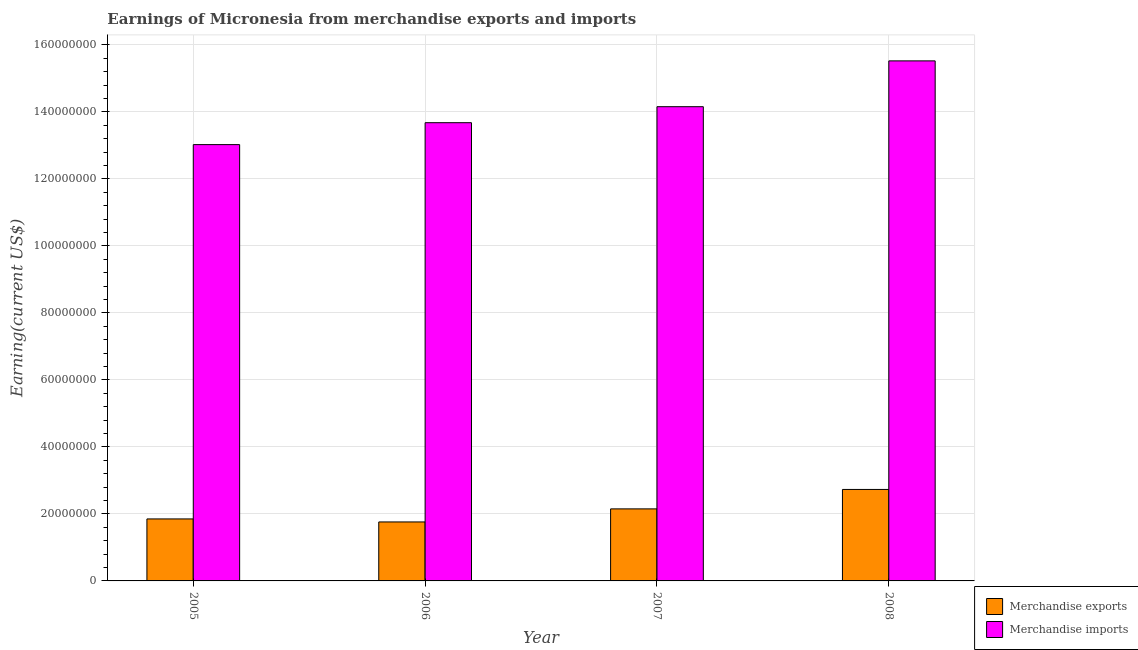How many different coloured bars are there?
Keep it short and to the point. 2. How many groups of bars are there?
Your answer should be very brief. 4. How many bars are there on the 1st tick from the left?
Your answer should be very brief. 2. In how many cases, is the number of bars for a given year not equal to the number of legend labels?
Offer a very short reply. 0. What is the earnings from merchandise imports in 2008?
Make the answer very short. 1.55e+08. Across all years, what is the maximum earnings from merchandise imports?
Your answer should be compact. 1.55e+08. Across all years, what is the minimum earnings from merchandise imports?
Ensure brevity in your answer.  1.30e+08. In which year was the earnings from merchandise exports maximum?
Make the answer very short. 2008. In which year was the earnings from merchandise exports minimum?
Offer a very short reply. 2006. What is the total earnings from merchandise imports in the graph?
Give a very brief answer. 5.64e+08. What is the difference between the earnings from merchandise imports in 2005 and that in 2008?
Offer a terse response. -2.50e+07. What is the difference between the earnings from merchandise exports in 2006 and the earnings from merchandise imports in 2007?
Provide a succinct answer. -3.90e+06. What is the average earnings from merchandise imports per year?
Offer a terse response. 1.41e+08. What is the ratio of the earnings from merchandise exports in 2005 to that in 2007?
Your answer should be compact. 0.86. Is the earnings from merchandise exports in 2005 less than that in 2008?
Your answer should be very brief. Yes. What is the difference between the highest and the second highest earnings from merchandise exports?
Offer a terse response. 5.80e+06. What is the difference between the highest and the lowest earnings from merchandise exports?
Provide a succinct answer. 9.70e+06. In how many years, is the earnings from merchandise exports greater than the average earnings from merchandise exports taken over all years?
Give a very brief answer. 2. What does the 1st bar from the right in 2005 represents?
Ensure brevity in your answer.  Merchandise imports. How many bars are there?
Give a very brief answer. 8. Are all the bars in the graph horizontal?
Offer a very short reply. No. How many years are there in the graph?
Offer a very short reply. 4. Are the values on the major ticks of Y-axis written in scientific E-notation?
Ensure brevity in your answer.  No. Does the graph contain any zero values?
Make the answer very short. No. Does the graph contain grids?
Your answer should be very brief. Yes. How are the legend labels stacked?
Provide a short and direct response. Vertical. What is the title of the graph?
Offer a terse response. Earnings of Micronesia from merchandise exports and imports. What is the label or title of the Y-axis?
Offer a terse response. Earning(current US$). What is the Earning(current US$) of Merchandise exports in 2005?
Your answer should be very brief. 1.85e+07. What is the Earning(current US$) in Merchandise imports in 2005?
Your response must be concise. 1.30e+08. What is the Earning(current US$) in Merchandise exports in 2006?
Give a very brief answer. 1.76e+07. What is the Earning(current US$) in Merchandise imports in 2006?
Give a very brief answer. 1.37e+08. What is the Earning(current US$) in Merchandise exports in 2007?
Give a very brief answer. 2.15e+07. What is the Earning(current US$) in Merchandise imports in 2007?
Your answer should be very brief. 1.42e+08. What is the Earning(current US$) in Merchandise exports in 2008?
Make the answer very short. 2.73e+07. What is the Earning(current US$) of Merchandise imports in 2008?
Your answer should be compact. 1.55e+08. Across all years, what is the maximum Earning(current US$) of Merchandise exports?
Provide a short and direct response. 2.73e+07. Across all years, what is the maximum Earning(current US$) of Merchandise imports?
Your answer should be very brief. 1.55e+08. Across all years, what is the minimum Earning(current US$) in Merchandise exports?
Give a very brief answer. 1.76e+07. Across all years, what is the minimum Earning(current US$) of Merchandise imports?
Provide a succinct answer. 1.30e+08. What is the total Earning(current US$) in Merchandise exports in the graph?
Ensure brevity in your answer.  8.49e+07. What is the total Earning(current US$) of Merchandise imports in the graph?
Your answer should be compact. 5.64e+08. What is the difference between the Earning(current US$) of Merchandise exports in 2005 and that in 2006?
Ensure brevity in your answer.  9.00e+05. What is the difference between the Earning(current US$) of Merchandise imports in 2005 and that in 2006?
Give a very brief answer. -6.54e+06. What is the difference between the Earning(current US$) in Merchandise imports in 2005 and that in 2007?
Ensure brevity in your answer.  -1.13e+07. What is the difference between the Earning(current US$) of Merchandise exports in 2005 and that in 2008?
Give a very brief answer. -8.80e+06. What is the difference between the Earning(current US$) in Merchandise imports in 2005 and that in 2008?
Offer a terse response. -2.50e+07. What is the difference between the Earning(current US$) of Merchandise exports in 2006 and that in 2007?
Your answer should be compact. -3.90e+06. What is the difference between the Earning(current US$) in Merchandise imports in 2006 and that in 2007?
Your answer should be compact. -4.77e+06. What is the difference between the Earning(current US$) in Merchandise exports in 2006 and that in 2008?
Provide a succinct answer. -9.70e+06. What is the difference between the Earning(current US$) in Merchandise imports in 2006 and that in 2008?
Make the answer very short. -1.84e+07. What is the difference between the Earning(current US$) of Merchandise exports in 2007 and that in 2008?
Make the answer very short. -5.80e+06. What is the difference between the Earning(current US$) in Merchandise imports in 2007 and that in 2008?
Keep it short and to the point. -1.37e+07. What is the difference between the Earning(current US$) of Merchandise exports in 2005 and the Earning(current US$) of Merchandise imports in 2006?
Your answer should be compact. -1.18e+08. What is the difference between the Earning(current US$) in Merchandise exports in 2005 and the Earning(current US$) in Merchandise imports in 2007?
Give a very brief answer. -1.23e+08. What is the difference between the Earning(current US$) in Merchandise exports in 2005 and the Earning(current US$) in Merchandise imports in 2008?
Make the answer very short. -1.37e+08. What is the difference between the Earning(current US$) of Merchandise exports in 2006 and the Earning(current US$) of Merchandise imports in 2007?
Your answer should be very brief. -1.24e+08. What is the difference between the Earning(current US$) in Merchandise exports in 2006 and the Earning(current US$) in Merchandise imports in 2008?
Offer a terse response. -1.38e+08. What is the difference between the Earning(current US$) of Merchandise exports in 2007 and the Earning(current US$) of Merchandise imports in 2008?
Keep it short and to the point. -1.34e+08. What is the average Earning(current US$) in Merchandise exports per year?
Make the answer very short. 2.12e+07. What is the average Earning(current US$) in Merchandise imports per year?
Give a very brief answer. 1.41e+08. In the year 2005, what is the difference between the Earning(current US$) in Merchandise exports and Earning(current US$) in Merchandise imports?
Provide a succinct answer. -1.12e+08. In the year 2006, what is the difference between the Earning(current US$) in Merchandise exports and Earning(current US$) in Merchandise imports?
Your response must be concise. -1.19e+08. In the year 2007, what is the difference between the Earning(current US$) of Merchandise exports and Earning(current US$) of Merchandise imports?
Your answer should be compact. -1.20e+08. In the year 2008, what is the difference between the Earning(current US$) in Merchandise exports and Earning(current US$) in Merchandise imports?
Offer a terse response. -1.28e+08. What is the ratio of the Earning(current US$) of Merchandise exports in 2005 to that in 2006?
Your answer should be very brief. 1.05. What is the ratio of the Earning(current US$) of Merchandise imports in 2005 to that in 2006?
Provide a short and direct response. 0.95. What is the ratio of the Earning(current US$) of Merchandise exports in 2005 to that in 2007?
Your response must be concise. 0.86. What is the ratio of the Earning(current US$) of Merchandise exports in 2005 to that in 2008?
Provide a succinct answer. 0.68. What is the ratio of the Earning(current US$) of Merchandise imports in 2005 to that in 2008?
Give a very brief answer. 0.84. What is the ratio of the Earning(current US$) of Merchandise exports in 2006 to that in 2007?
Provide a short and direct response. 0.82. What is the ratio of the Earning(current US$) of Merchandise imports in 2006 to that in 2007?
Provide a succinct answer. 0.97. What is the ratio of the Earning(current US$) of Merchandise exports in 2006 to that in 2008?
Your response must be concise. 0.64. What is the ratio of the Earning(current US$) in Merchandise imports in 2006 to that in 2008?
Offer a terse response. 0.88. What is the ratio of the Earning(current US$) in Merchandise exports in 2007 to that in 2008?
Keep it short and to the point. 0.79. What is the ratio of the Earning(current US$) of Merchandise imports in 2007 to that in 2008?
Offer a terse response. 0.91. What is the difference between the highest and the second highest Earning(current US$) of Merchandise exports?
Ensure brevity in your answer.  5.80e+06. What is the difference between the highest and the second highest Earning(current US$) in Merchandise imports?
Provide a short and direct response. 1.37e+07. What is the difference between the highest and the lowest Earning(current US$) of Merchandise exports?
Ensure brevity in your answer.  9.70e+06. What is the difference between the highest and the lowest Earning(current US$) in Merchandise imports?
Provide a short and direct response. 2.50e+07. 